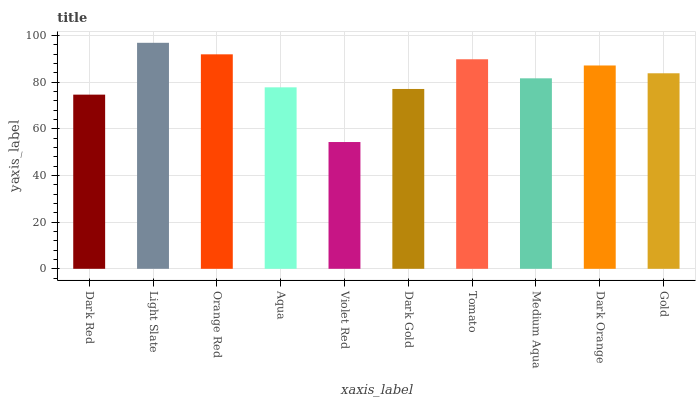Is Orange Red the minimum?
Answer yes or no. No. Is Orange Red the maximum?
Answer yes or no. No. Is Light Slate greater than Orange Red?
Answer yes or no. Yes. Is Orange Red less than Light Slate?
Answer yes or no. Yes. Is Orange Red greater than Light Slate?
Answer yes or no. No. Is Light Slate less than Orange Red?
Answer yes or no. No. Is Gold the high median?
Answer yes or no. Yes. Is Medium Aqua the low median?
Answer yes or no. Yes. Is Dark Orange the high median?
Answer yes or no. No. Is Gold the low median?
Answer yes or no. No. 